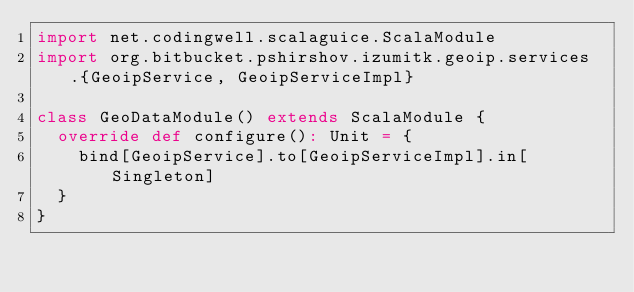<code> <loc_0><loc_0><loc_500><loc_500><_Scala_>import net.codingwell.scalaguice.ScalaModule
import org.bitbucket.pshirshov.izumitk.geoip.services.{GeoipService, GeoipServiceImpl}

class GeoDataModule() extends ScalaModule {
  override def configure(): Unit = {
    bind[GeoipService].to[GeoipServiceImpl].in[Singleton]
  }
}</code> 